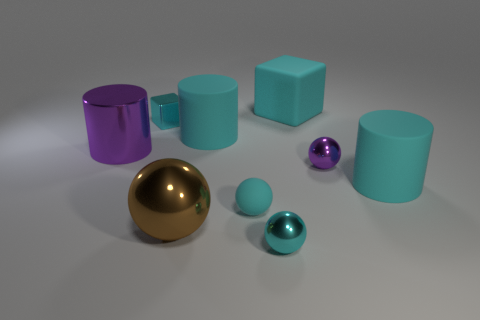Subtract all brown spheres. How many cyan cylinders are left? 2 Subtract all tiny spheres. How many spheres are left? 1 Subtract 1 balls. How many balls are left? 3 Subtract all purple balls. How many balls are left? 3 Subtract all brown cylinders. Subtract all purple cubes. How many cylinders are left? 3 Subtract all balls. How many objects are left? 5 Add 5 tiny brown things. How many tiny brown things exist? 5 Subtract 0 gray cylinders. How many objects are left? 9 Subtract all big cyan blocks. Subtract all small cyan matte objects. How many objects are left? 7 Add 6 cyan blocks. How many cyan blocks are left? 8 